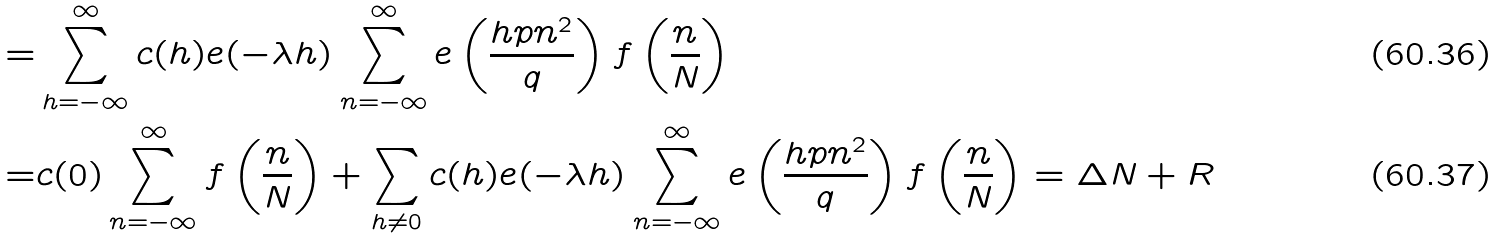<formula> <loc_0><loc_0><loc_500><loc_500>= & \sum _ { h = - \infty } ^ { \infty } c ( h ) e ( - \lambda h ) \sum _ { n = - \infty } ^ { \infty } e \left ( \frac { h p n ^ { 2 } } { q } \right ) f \left ( \frac { n } { N } \right ) \\ = & c ( 0 ) \sum _ { n = - \infty } ^ { \infty } f \left ( \frac { n } { N } \right ) + \sum _ { h \neq 0 } c ( h ) e ( - \lambda h ) \sum _ { n = - \infty } ^ { \infty } e \left ( \frac { h p n ^ { 2 } } { q } \right ) f \left ( \frac { n } { N } \right ) = \Delta N + R</formula> 